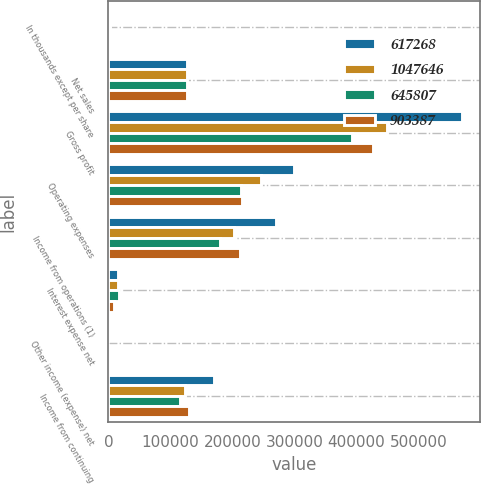<chart> <loc_0><loc_0><loc_500><loc_500><stacked_bar_chart><ecel><fcel>In thousands except per share<fcel>Net sales<fcel>Gross profit<fcel>Operating expenses<fcel>Income from operations (1)<fcel>Interest expense net<fcel>Other income (expense) net<fcel>Income from continuing<nl><fcel>617268<fcel>2011<fcel>126826<fcel>570424<fcel>299723<fcel>270701<fcel>15007<fcel>380<fcel>170149<nl><fcel>1.04765e+06<fcel>2010<fcel>126826<fcel>449078<fcel>246268<fcel>202810<fcel>15923<fcel>60<fcel>123099<nl><fcel>645807<fcel>2009<fcel>126826<fcel>393326<fcel>213294<fcel>180032<fcel>16674<fcel>1<fcel>115055<nl><fcel>903387<fcel>2008<fcel>126826<fcel>427186<fcel>214670<fcel>212516<fcel>8508<fcel>292<fcel>130554<nl></chart> 